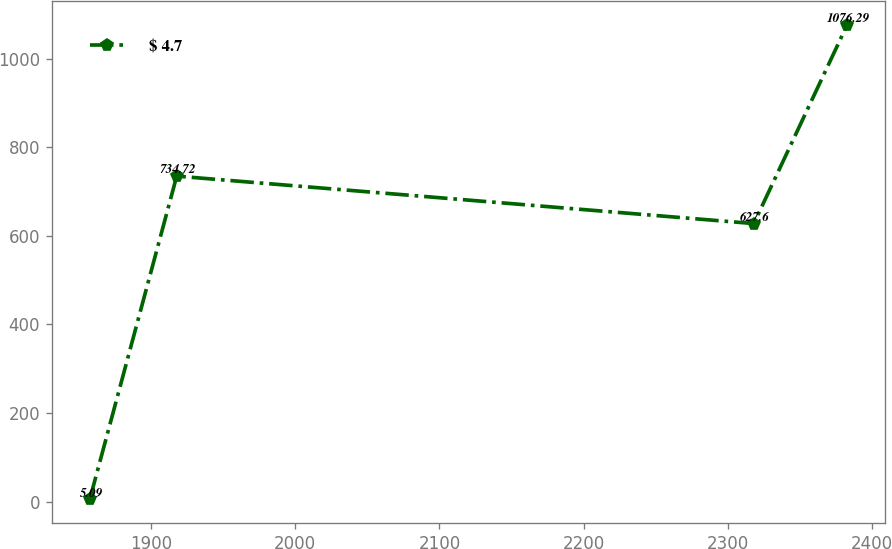<chart> <loc_0><loc_0><loc_500><loc_500><line_chart><ecel><fcel>$ 4.7<nl><fcel>1857.67<fcel>5.09<nl><fcel>1917.94<fcel>734.72<nl><fcel>2317.92<fcel>627.6<nl><fcel>2382.64<fcel>1076.29<nl></chart> 